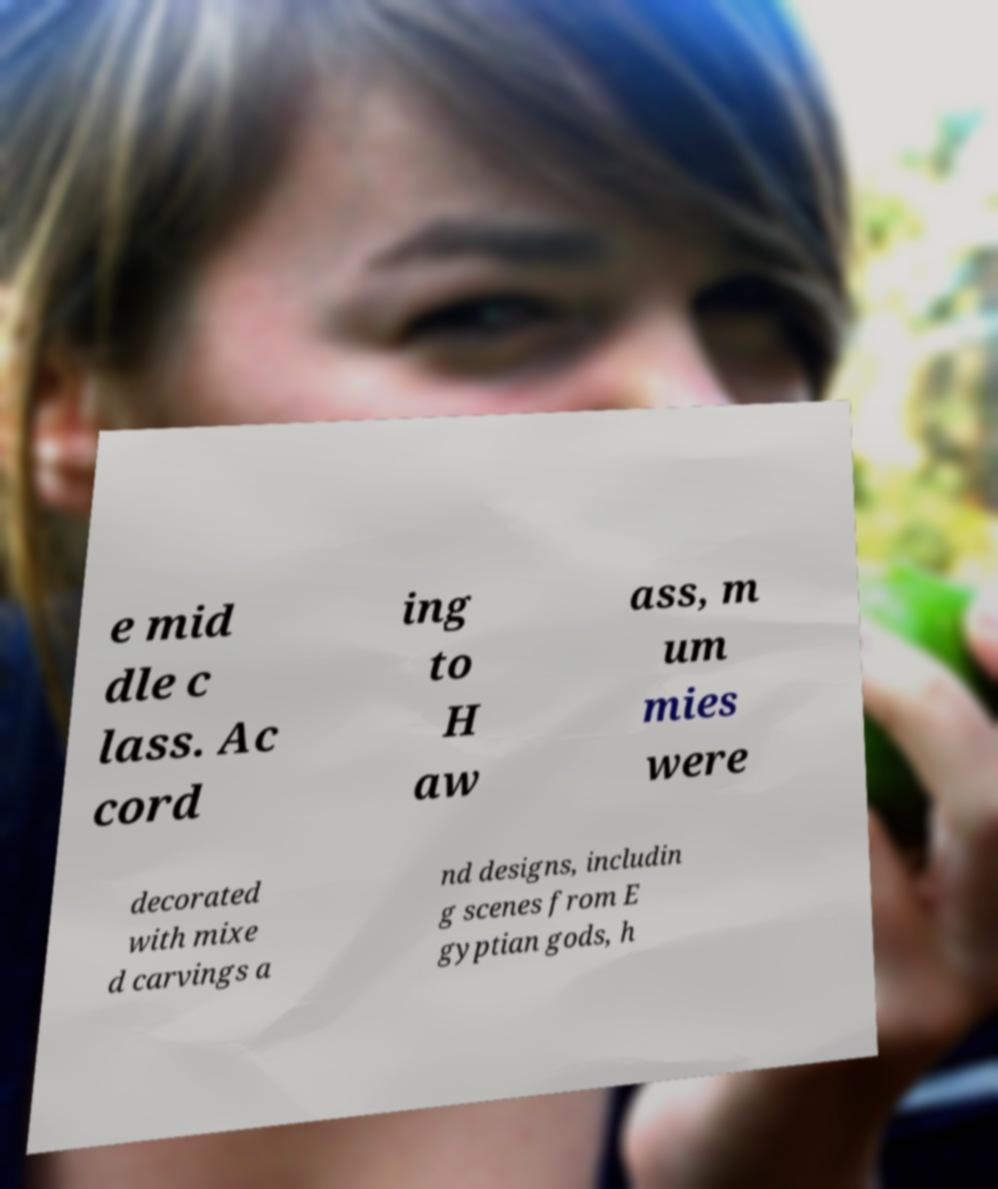For documentation purposes, I need the text within this image transcribed. Could you provide that? e mid dle c lass. Ac cord ing to H aw ass, m um mies were decorated with mixe d carvings a nd designs, includin g scenes from E gyptian gods, h 